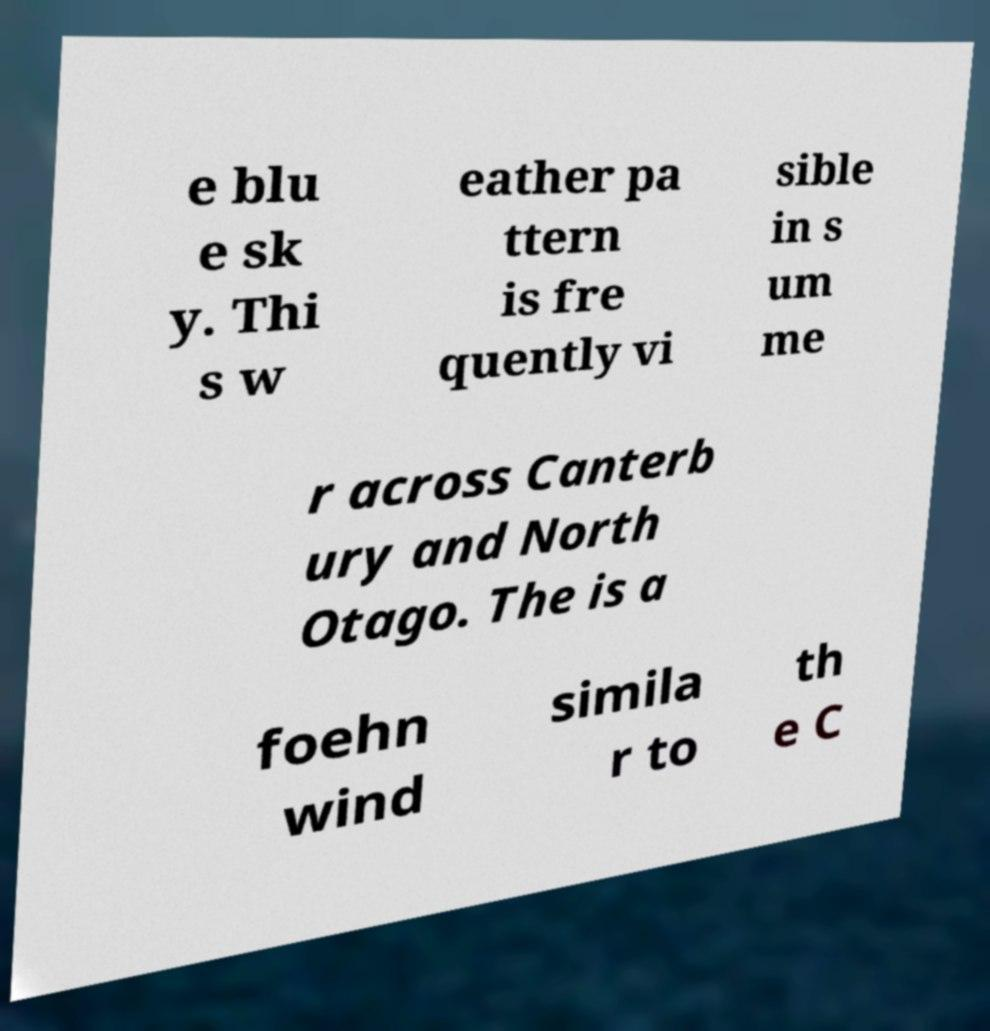Could you assist in decoding the text presented in this image and type it out clearly? e blu e sk y. Thi s w eather pa ttern is fre quently vi sible in s um me r across Canterb ury and North Otago. The is a foehn wind simila r to th e C 